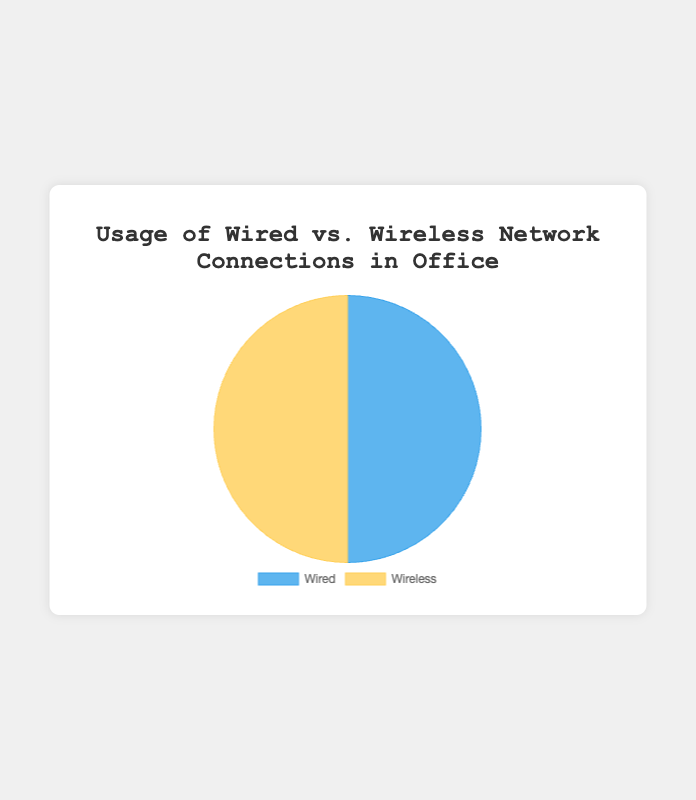How many employees in total are using wired network connections? To find the total number of employees using a wired network connection, we sum up the users from each department listed under the wired network data points: Finance (50) + HR (10) + IT (20) + Sales (5) + Marketing (15). This gives a total of 50 + 10 + 20 + 5 + 15 = 100.
Answer: 100 Which connection type has a greater number of users? Comparing the sum of users, the wired network has 100 users and the wireless network has 100 users. Therefore, both connection types have an equal number of users.
Answer: Both are equal What percentage of total users does the Wireless connection have? To find the percentage, we use the formula (number of wireless users / total users) * 100. We know there are 100 wireless users out of a total of 200 users. So, (100 / 200) * 100 = 50%.
Answer: 50% Among the listed departments, which one has the highest number of Wireless connection users? From the wireless network data points, we look at the users in each department: Finance (10), HR (20), IT (10), Sales (25), Marketing (35). The Marketing department has the highest number of wireless users with 35.
Answer: Marketing How many more users does the IT department have on Wired connection compared to Wireless? To find the difference, we subtract the number of wireless users from wired users in the IT department: Wired (20) - Wireless (10) = 10.
Answer: 10 If the company plans to upgrade the network and it will cost $50 per wired connection and $40 per wireless connection, what would be the total cost? First, calculate the total cost for wired connections by multiplying the number of wired users by $50: 100 * 50 = $5000. Then, calculate the total cost for wireless connections by multiplying the number of wireless users by $40: 100 * 40 = $4000. Adding these together, $5000 + $4000 gives a total cost of $9000.
Answer: $9000 Which department has an equal number of wired and wireless users? We look at the wired and wireless users for each department. The IT department has 20 wired users and 20 wireless users, which are equal.
Answer: IT What is the difference in the number of users between the department with the highest wired connection usage and the department with the highest wireless connection usage? The department with the highest wired usage is Finance (50 users). The department with the highest wireless usage is Marketing (35 users). The difference is 50 - 35 = 15.
Answer: 15 How many departments have more users on Wireless connection than Wired connection? By comparing each department, Finance has more wired (50 vs. 10). HR has more wireless (10 vs. 20). IT has equal (20 each). Sales has more wireless (5 vs. 25). Marketing has more wireless (15 vs. 35). This means HR, Sales, and Marketing have more wireless users. Thus, 3 departments have more wireless users.
Answer: 3 